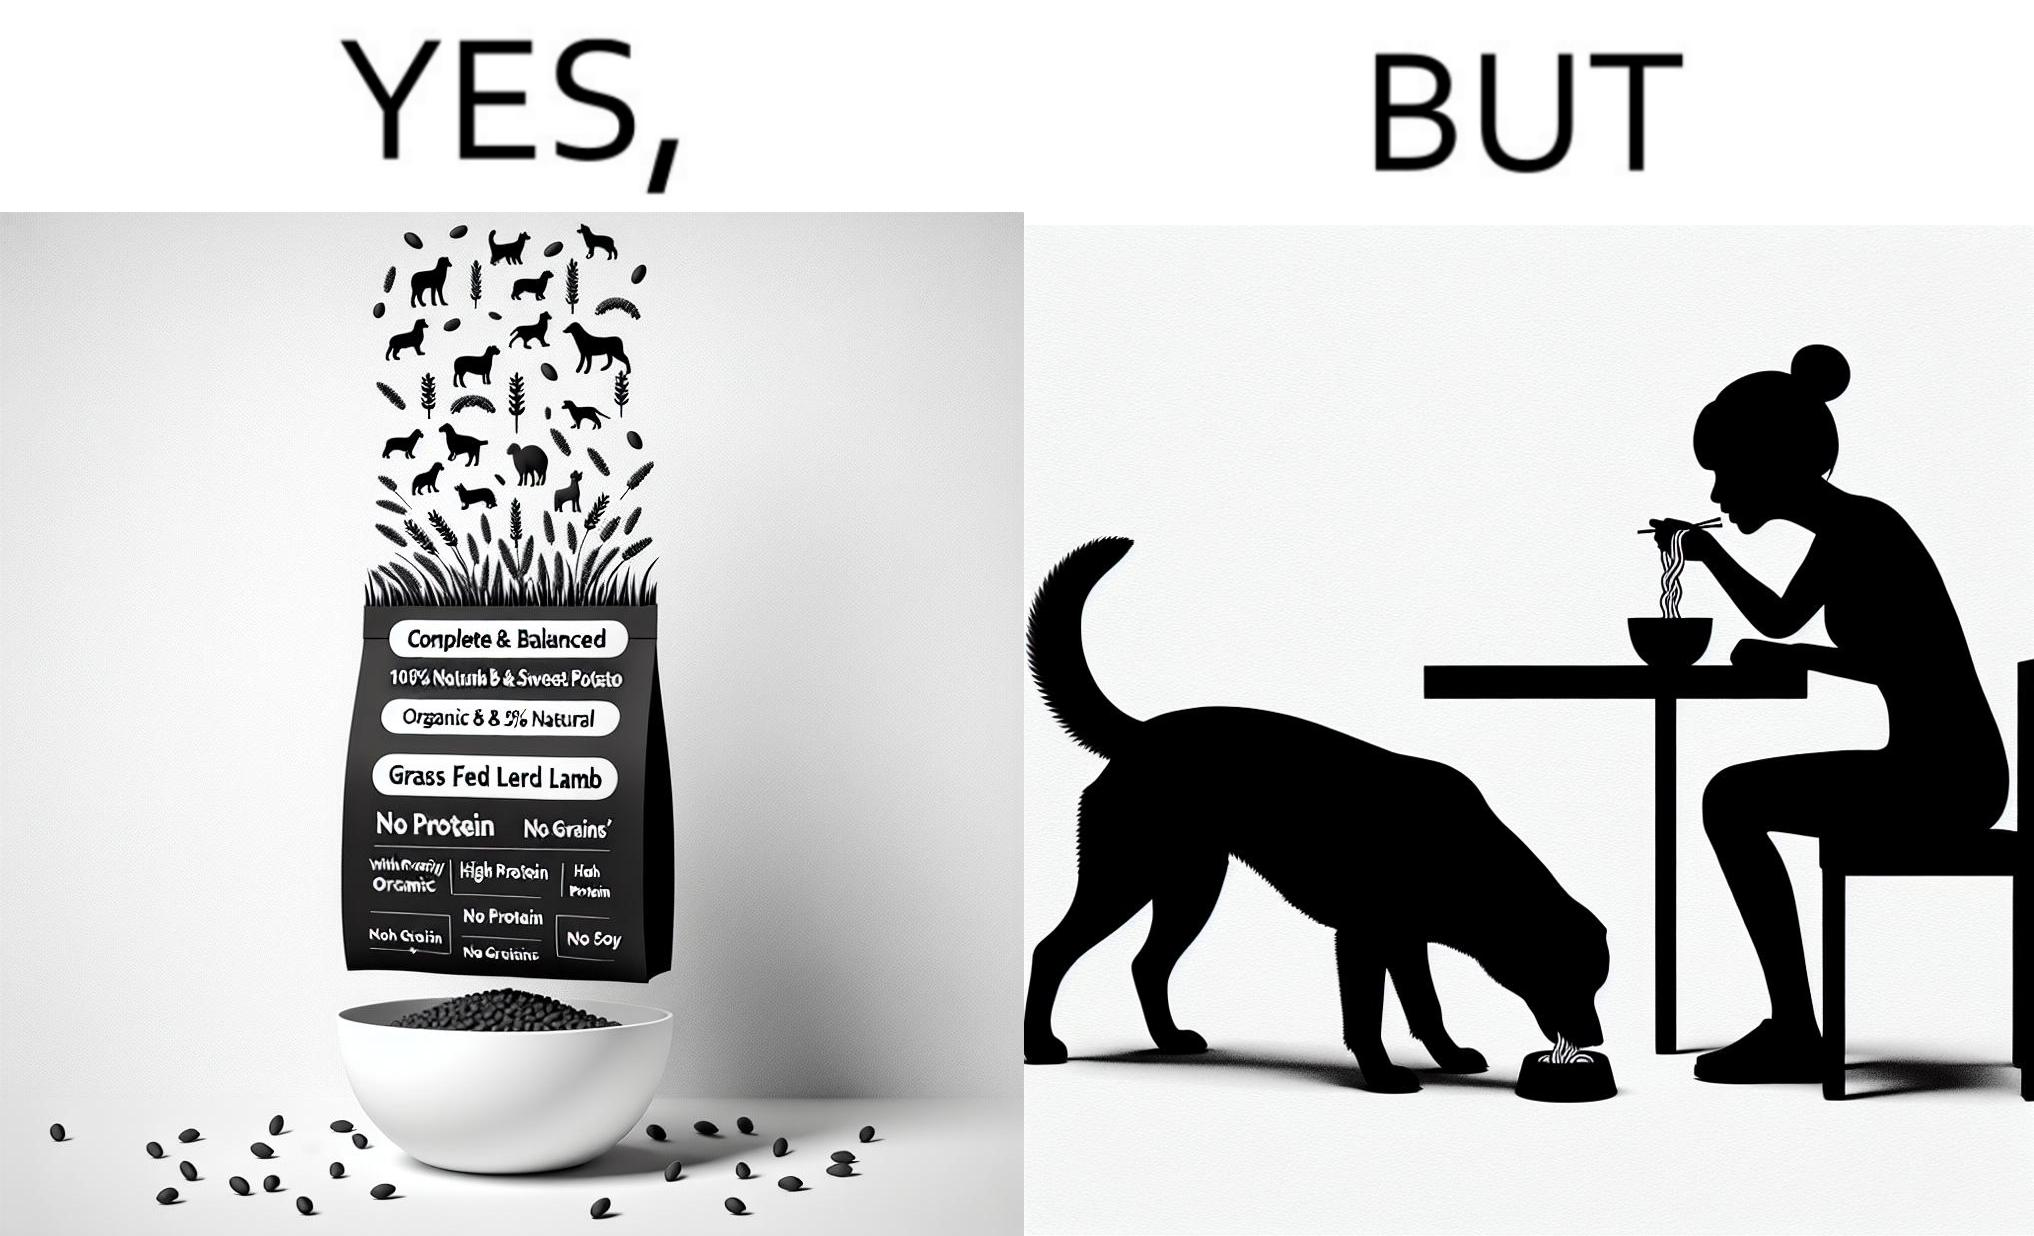Is this a satirical image? Yes, this image is satirical. 